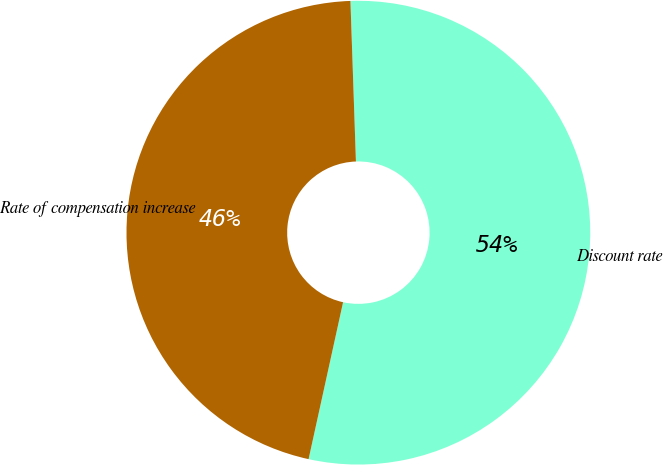Convert chart. <chart><loc_0><loc_0><loc_500><loc_500><pie_chart><fcel>Discount rate<fcel>Rate of compensation increase<nl><fcel>53.99%<fcel>46.01%<nl></chart> 